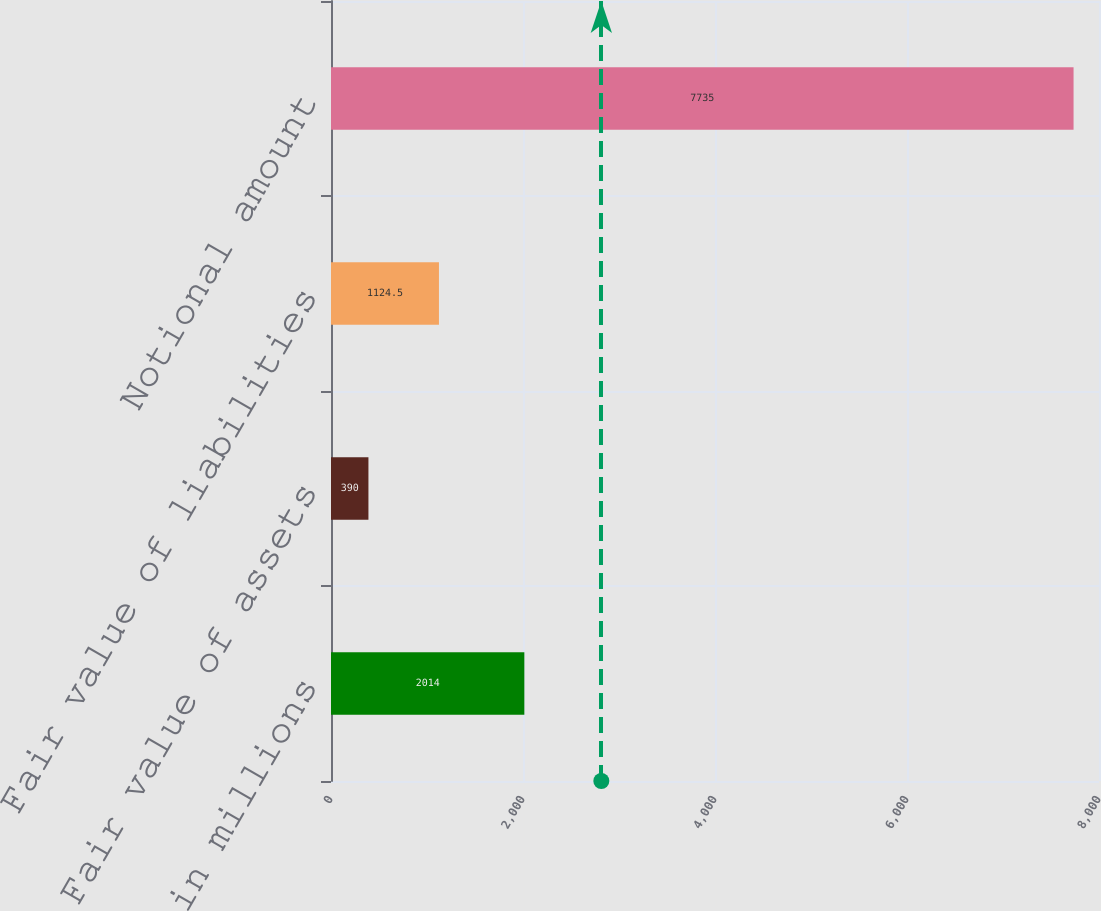Convert chart to OTSL. <chart><loc_0><loc_0><loc_500><loc_500><bar_chart><fcel>in millions<fcel>Fair value of assets<fcel>Fair value of liabilities<fcel>Notional amount<nl><fcel>2014<fcel>390<fcel>1124.5<fcel>7735<nl></chart> 